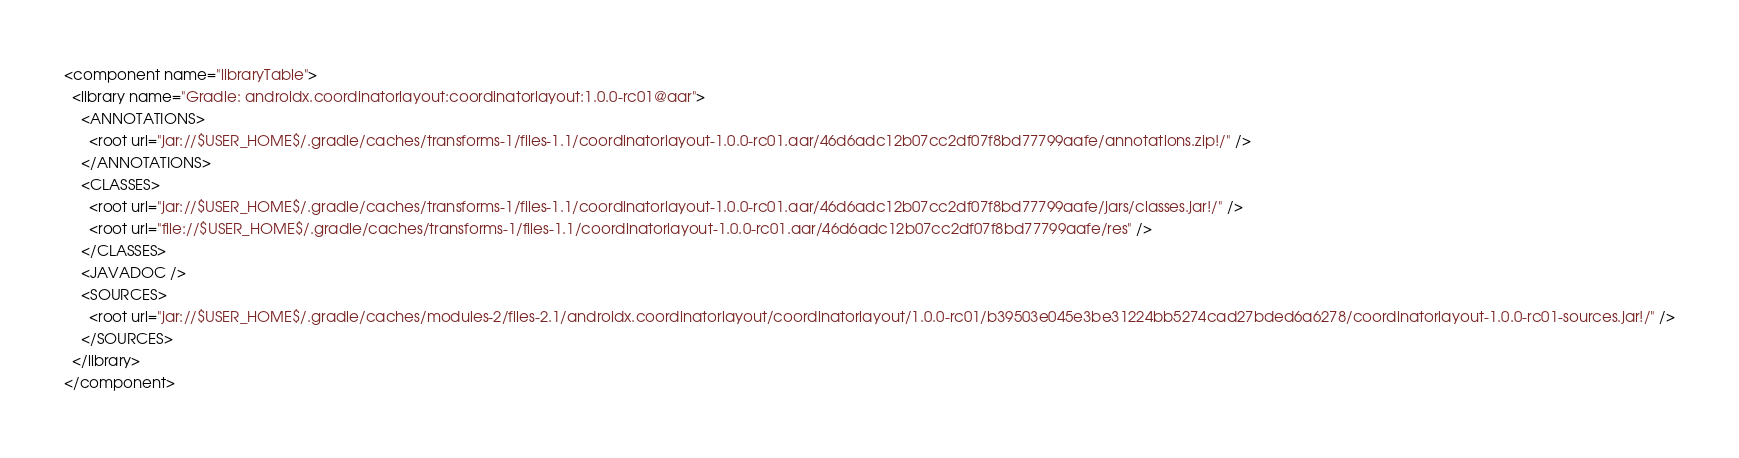<code> <loc_0><loc_0><loc_500><loc_500><_XML_><component name="libraryTable">
  <library name="Gradle: androidx.coordinatorlayout:coordinatorlayout:1.0.0-rc01@aar">
    <ANNOTATIONS>
      <root url="jar://$USER_HOME$/.gradle/caches/transforms-1/files-1.1/coordinatorlayout-1.0.0-rc01.aar/46d6adc12b07cc2df07f8bd77799aafe/annotations.zip!/" />
    </ANNOTATIONS>
    <CLASSES>
      <root url="jar://$USER_HOME$/.gradle/caches/transforms-1/files-1.1/coordinatorlayout-1.0.0-rc01.aar/46d6adc12b07cc2df07f8bd77799aafe/jars/classes.jar!/" />
      <root url="file://$USER_HOME$/.gradle/caches/transforms-1/files-1.1/coordinatorlayout-1.0.0-rc01.aar/46d6adc12b07cc2df07f8bd77799aafe/res" />
    </CLASSES>
    <JAVADOC />
    <SOURCES>
      <root url="jar://$USER_HOME$/.gradle/caches/modules-2/files-2.1/androidx.coordinatorlayout/coordinatorlayout/1.0.0-rc01/b39503e045e3be31224bb5274cad27bded6a6278/coordinatorlayout-1.0.0-rc01-sources.jar!/" />
    </SOURCES>
  </library>
</component></code> 